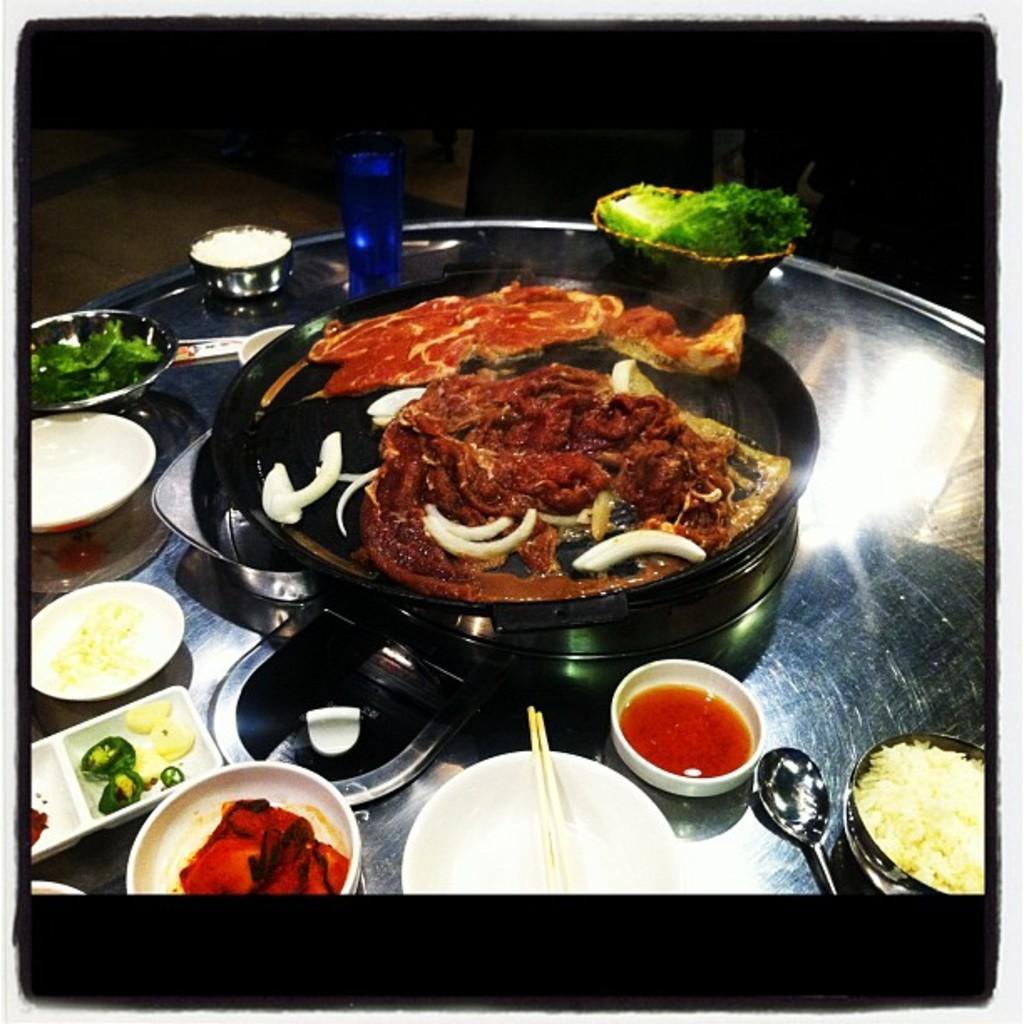How would you summarize this image in a sentence or two? In this image we can see some food in the containers. 